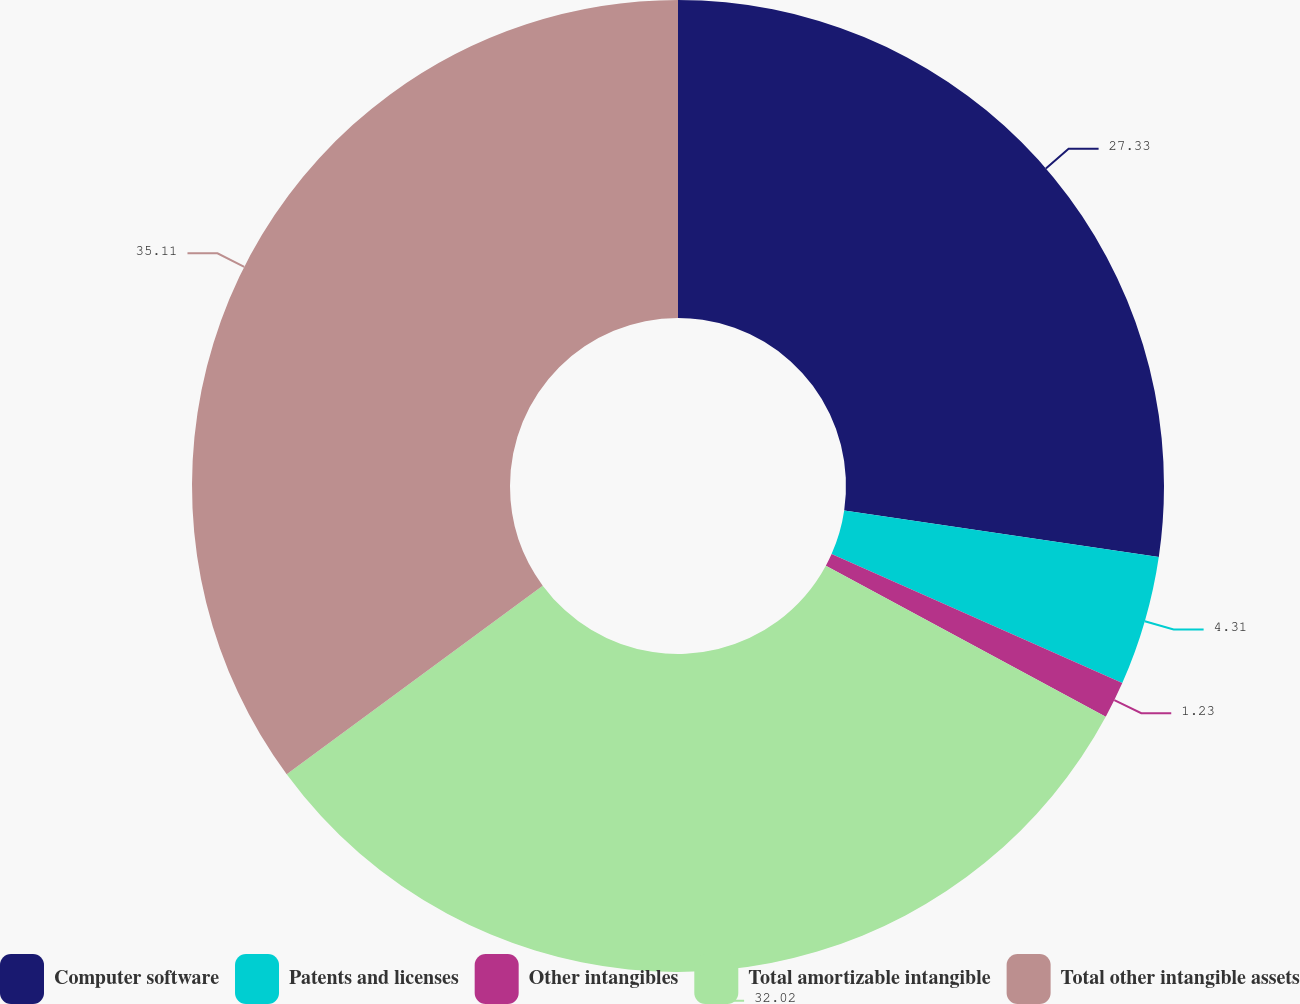Convert chart. <chart><loc_0><loc_0><loc_500><loc_500><pie_chart><fcel>Computer software<fcel>Patents and licenses<fcel>Other intangibles<fcel>Total amortizable intangible<fcel>Total other intangible assets<nl><fcel>27.33%<fcel>4.31%<fcel>1.23%<fcel>32.02%<fcel>35.1%<nl></chart> 